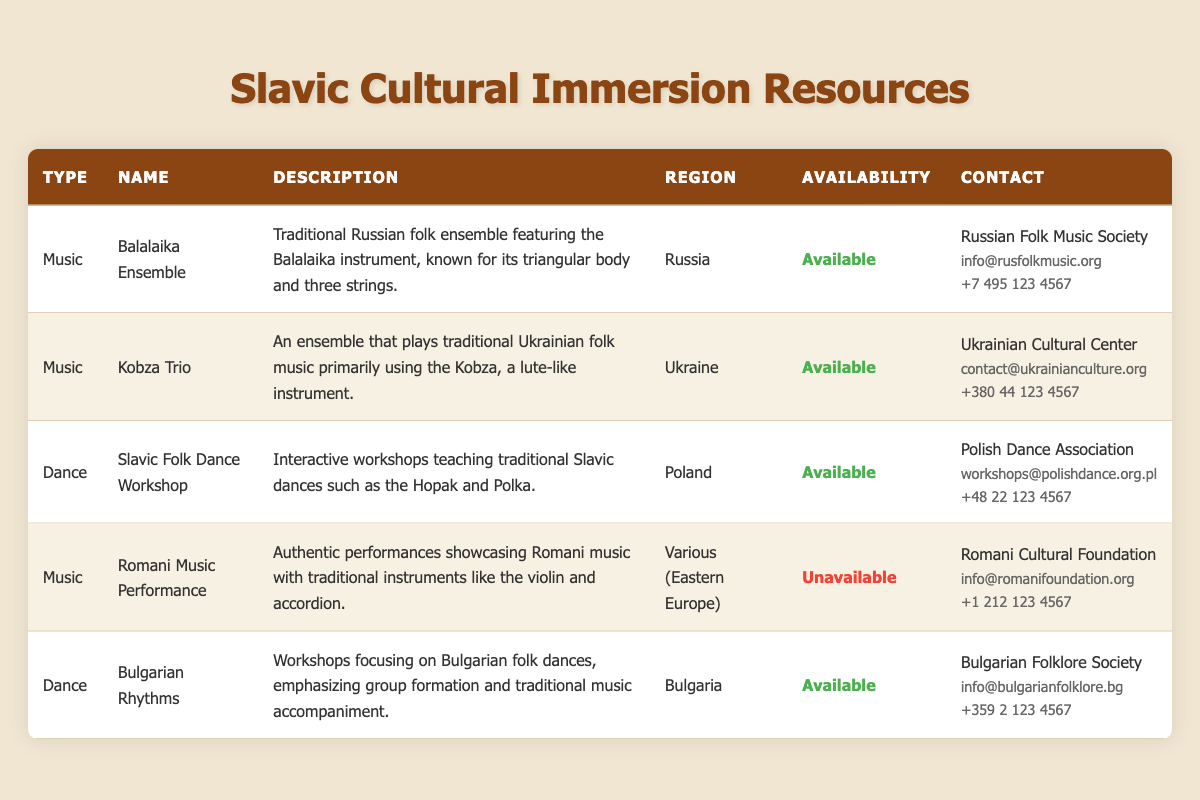What types of resources are available for workshops? The table lists two types of resources: Music and Dance. Under Music, there are the Balalaika Ensemble, Kobza Trio, and Romani Music Performance. Under Dance, there are the Slavic Folk Dance Workshop and Bulgarian Rhythms.
Answer: Music and Dance Which resource is from Bulgaria? The only resource listed from Bulgaria is "Bulgarian Rhythms," which focuses on workshops for Bulgarian folk dances.
Answer: Bulgarian Rhythms Is the Romani Music Performance available for workshops? Looking at the table, the availability status of the Romani Music Performance indicates that it is "Unavailable."
Answer: No What is the contact information for the Kobza Trio? According to the table, the Kobza Trio is associated with the Ukrainian Cultural Center, and its contact information includes the email contact@ukrainianculture.org and the phone number +380 44 123 4567.
Answer: Ukrainian Cultural Center; contact@ukrainianculture.org; +380 44 123 4567 How many resources are available for workshops in total? From the table, there are five listed resources. Out of these, Balalaika Ensemble, Kobza Trio, Slavic Folk Dance Workshop, and Bulgarian Rhythms are available, giving us a total of four resources available for workshops.
Answer: Four Which resource involves performances and is unavailable for workshops? The resource that involves performances and is unavailable for workshops is the "Romani Music Performance," which showcases Romani music with traditional instruments.
Answer: Romani Music Performance What is the average number of resources available from each region listed in the table? There are resources from four different regions (Russia, Ukraine, Poland, and Bulgaria), with a total of four available resources: Balalaika Ensemble, Kobza Trio, Slavic Folk Dance Workshop, and Bulgarian Rhythms. So, the average would be 4 resources divided by 4 regions, resulting in an average of 1 resource per region.
Answer: One resource per region Which organization can be contacted for the Slavic Folk Dance Workshop? The Slavic Folk Dance Workshop is organized by the Polish Dance Association. The contact email is workshops@polishdance.org.pl and the phone number is +48 22 123 4567.
Answer: Polish Dance Association; workshops@polishdance.org.pl; +48 22 123 4567 